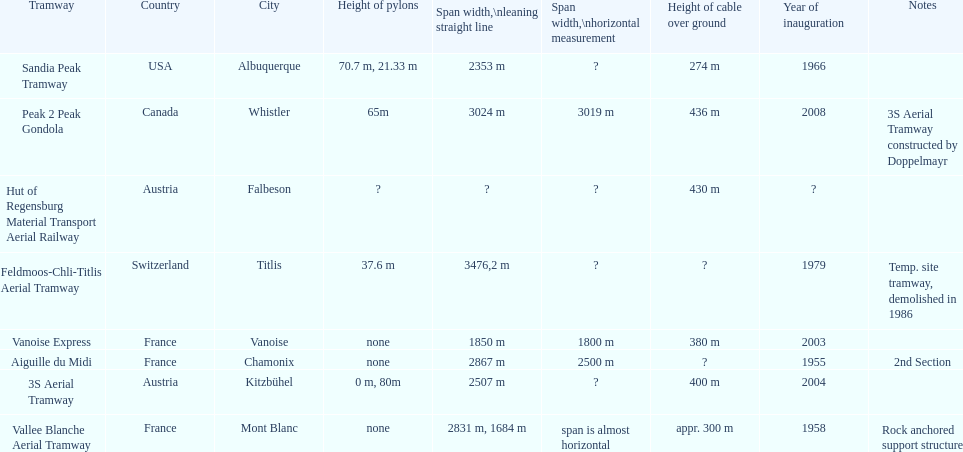How many aerial tramways are located in france? 3. 